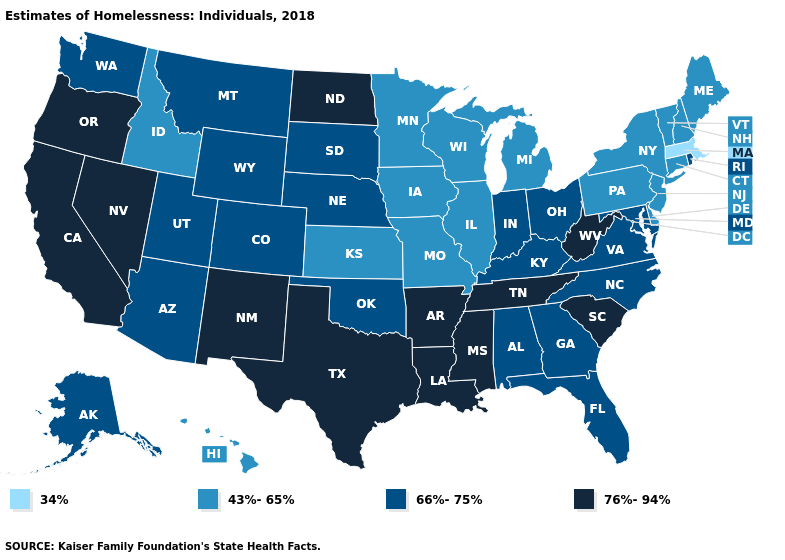What is the value of Idaho?
Quick response, please. 43%-65%. Name the states that have a value in the range 76%-94%?
Be succinct. Arkansas, California, Louisiana, Mississippi, Nevada, New Mexico, North Dakota, Oregon, South Carolina, Tennessee, Texas, West Virginia. Does Nevada have the same value as Virginia?
Answer briefly. No. Among the states that border Utah , does Arizona have the lowest value?
Give a very brief answer. No. What is the lowest value in the MidWest?
Keep it brief. 43%-65%. What is the value of Wisconsin?
Quick response, please. 43%-65%. What is the lowest value in the USA?
Write a very short answer. 34%. Among the states that border Kansas , which have the lowest value?
Quick response, please. Missouri. Does Mississippi have a higher value than Wisconsin?
Short answer required. Yes. What is the highest value in states that border Pennsylvania?
Concise answer only. 76%-94%. Does the map have missing data?
Answer briefly. No. Name the states that have a value in the range 43%-65%?
Be succinct. Connecticut, Delaware, Hawaii, Idaho, Illinois, Iowa, Kansas, Maine, Michigan, Minnesota, Missouri, New Hampshire, New Jersey, New York, Pennsylvania, Vermont, Wisconsin. Does Virginia have a lower value than Oregon?
Quick response, please. Yes. Name the states that have a value in the range 43%-65%?
Be succinct. Connecticut, Delaware, Hawaii, Idaho, Illinois, Iowa, Kansas, Maine, Michigan, Minnesota, Missouri, New Hampshire, New Jersey, New York, Pennsylvania, Vermont, Wisconsin. What is the value of Washington?
Give a very brief answer. 66%-75%. 